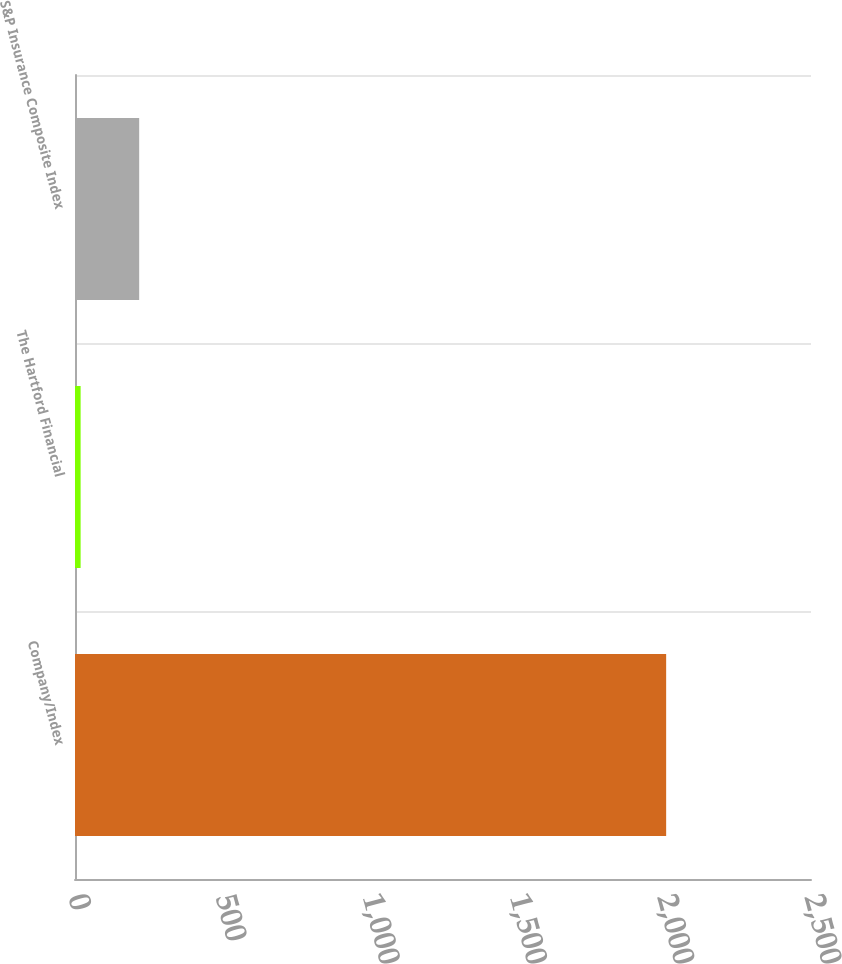<chart> <loc_0><loc_0><loc_500><loc_500><bar_chart><fcel>Company/Index<fcel>The Hartford Financial<fcel>S&P Insurance Composite Index<nl><fcel>2008<fcel>19.1<fcel>217.99<nl></chart> 